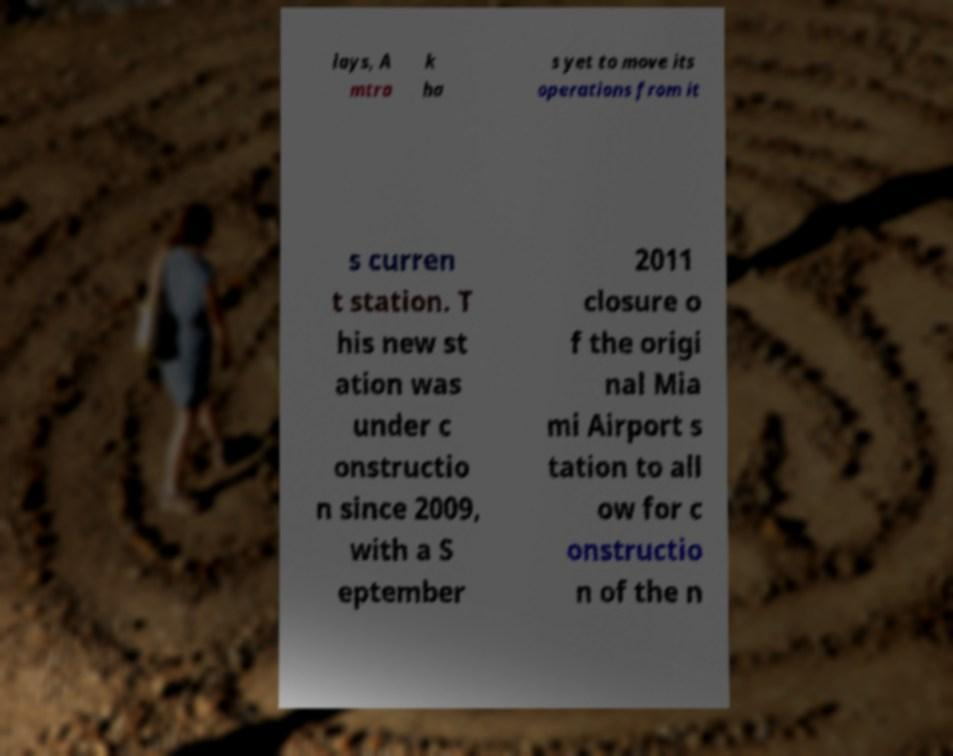For documentation purposes, I need the text within this image transcribed. Could you provide that? lays, A mtra k ha s yet to move its operations from it s curren t station. T his new st ation was under c onstructio n since 2009, with a S eptember 2011 closure o f the origi nal Mia mi Airport s tation to all ow for c onstructio n of the n 